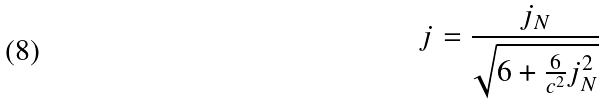<formula> <loc_0><loc_0><loc_500><loc_500>j = \frac { j _ { N } } { \sqrt { 6 + \frac { 6 } { c ^ { 2 } } j _ { N } ^ { 2 } } }</formula> 